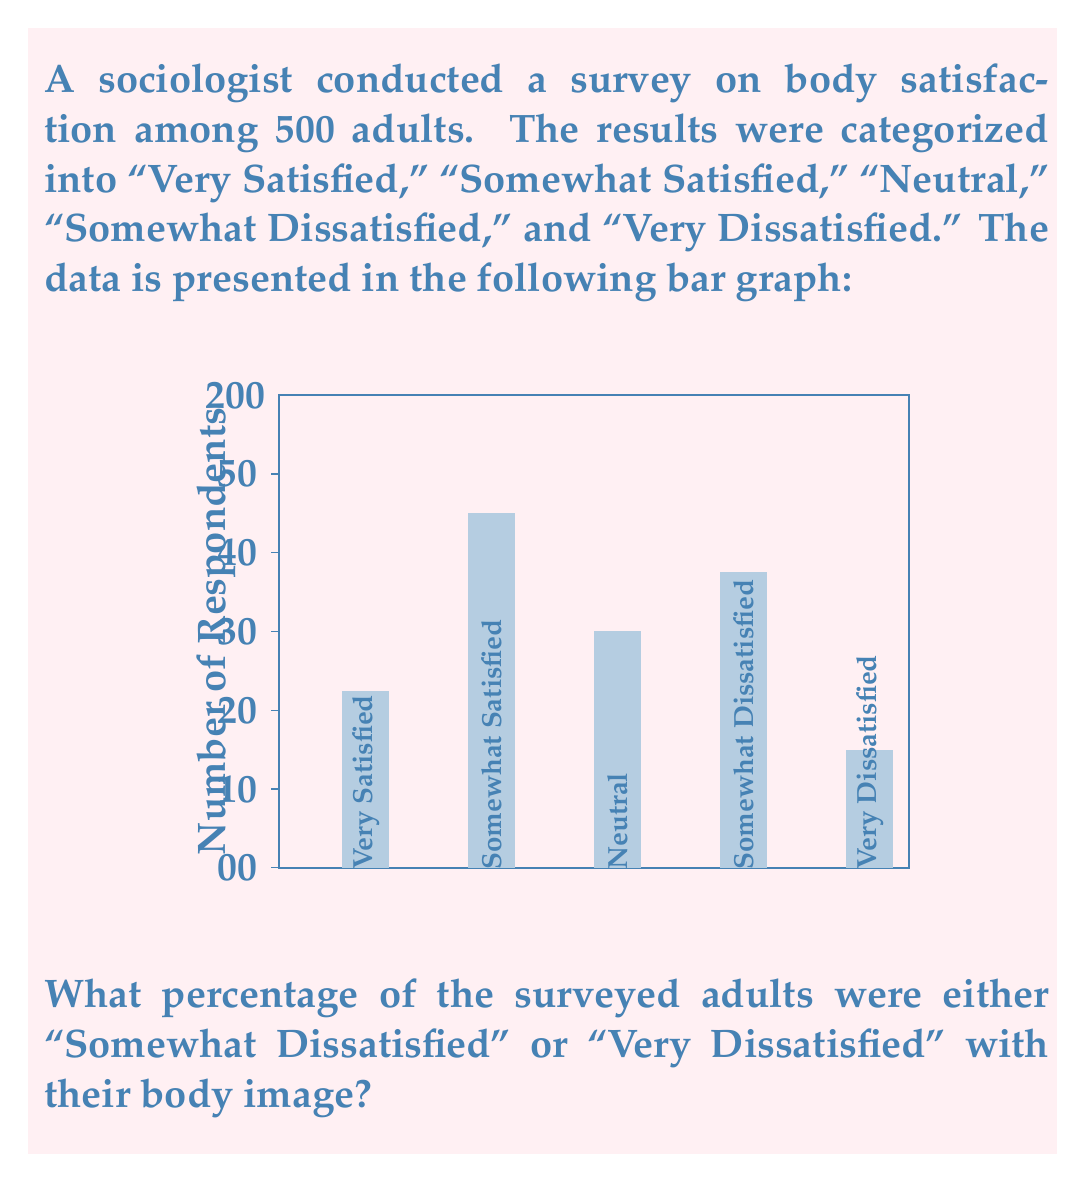Can you solve this math problem? To solve this problem, we need to follow these steps:

1. Identify the number of respondents who were "Somewhat Dissatisfied" and "Very Dissatisfied":
   - Somewhat Dissatisfied: 125 respondents
   - Very Dissatisfied: 50 respondents

2. Calculate the total number of respondents in these two categories:
   $$ 125 + 50 = 175 $$

3. Calculate the total number of survey respondents:
   $$ 75 + 150 + 100 + 125 + 50 = 500 $$

4. Calculate the percentage by dividing the number of dissatisfied respondents by the total number of respondents and multiplying by 100:

   $$ \text{Percentage} = \frac{\text{Number of dissatisfied respondents}}{\text{Total number of respondents}} \times 100 $$
   
   $$ \text{Percentage} = \frac{175}{500} \times 100 $$

5. Simplify the fraction and calculate:
   $$ \text{Percentage} = 0.35 \times 100 = 35\% $$

Therefore, 35% of the surveyed adults were either "Somewhat Dissatisfied" or "Very Dissatisfied" with their body image.
Answer: 35% 